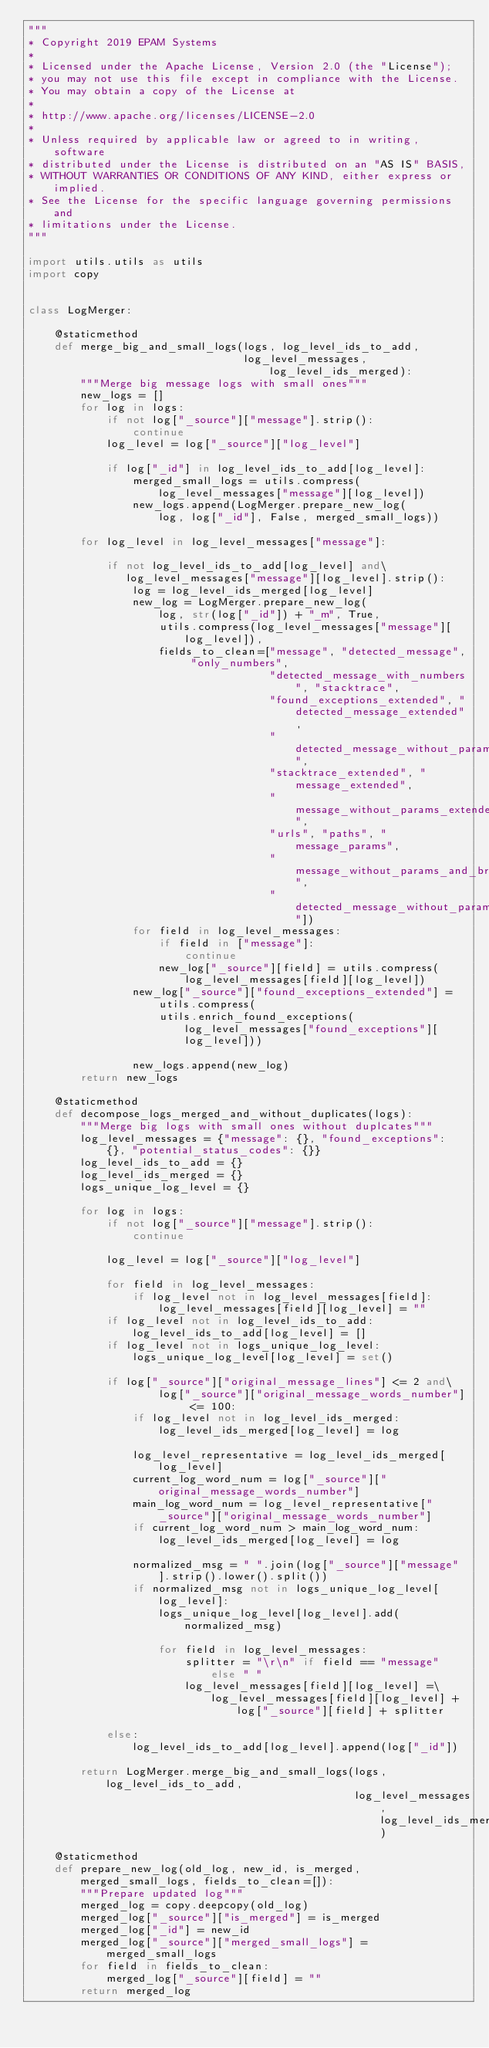<code> <loc_0><loc_0><loc_500><loc_500><_Python_>"""
* Copyright 2019 EPAM Systems
*
* Licensed under the Apache License, Version 2.0 (the "License");
* you may not use this file except in compliance with the License.
* You may obtain a copy of the License at
*
* http://www.apache.org/licenses/LICENSE-2.0
*
* Unless required by applicable law or agreed to in writing, software
* distributed under the License is distributed on an "AS IS" BASIS,
* WITHOUT WARRANTIES OR CONDITIONS OF ANY KIND, either express or implied.
* See the License for the specific language governing permissions and
* limitations under the License.
"""

import utils.utils as utils
import copy


class LogMerger:

    @staticmethod
    def merge_big_and_small_logs(logs, log_level_ids_to_add,
                                 log_level_messages, log_level_ids_merged):
        """Merge big message logs with small ones"""
        new_logs = []
        for log in logs:
            if not log["_source"]["message"].strip():
                continue
            log_level = log["_source"]["log_level"]

            if log["_id"] in log_level_ids_to_add[log_level]:
                merged_small_logs = utils.compress(log_level_messages["message"][log_level])
                new_logs.append(LogMerger.prepare_new_log(
                    log, log["_id"], False, merged_small_logs))

        for log_level in log_level_messages["message"]:

            if not log_level_ids_to_add[log_level] and\
               log_level_messages["message"][log_level].strip():
                log = log_level_ids_merged[log_level]
                new_log = LogMerger.prepare_new_log(
                    log, str(log["_id"]) + "_m", True,
                    utils.compress(log_level_messages["message"][log_level]),
                    fields_to_clean=["message", "detected_message", "only_numbers",
                                     "detected_message_with_numbers", "stacktrace",
                                     "found_exceptions_extended", "detected_message_extended",
                                     "detected_message_without_params_extended",
                                     "stacktrace_extended", "message_extended",
                                     "message_without_params_extended",
                                     "urls", "paths", "message_params",
                                     "message_without_params_and_brackets",
                                     "detected_message_without_params_and_brackets"])
                for field in log_level_messages:
                    if field in ["message"]:
                        continue
                    new_log["_source"][field] = utils.compress(
                        log_level_messages[field][log_level])
                new_log["_source"]["found_exceptions_extended"] = utils.compress(
                    utils.enrich_found_exceptions(log_level_messages["found_exceptions"][log_level]))

                new_logs.append(new_log)
        return new_logs

    @staticmethod
    def decompose_logs_merged_and_without_duplicates(logs):
        """Merge big logs with small ones without duplcates"""
        log_level_messages = {"message": {}, "found_exceptions": {}, "potential_status_codes": {}}
        log_level_ids_to_add = {}
        log_level_ids_merged = {}
        logs_unique_log_level = {}

        for log in logs:
            if not log["_source"]["message"].strip():
                continue

            log_level = log["_source"]["log_level"]

            for field in log_level_messages:
                if log_level not in log_level_messages[field]:
                    log_level_messages[field][log_level] = ""
            if log_level not in log_level_ids_to_add:
                log_level_ids_to_add[log_level] = []
            if log_level not in logs_unique_log_level:
                logs_unique_log_level[log_level] = set()

            if log["_source"]["original_message_lines"] <= 2 and\
                    log["_source"]["original_message_words_number"] <= 100:
                if log_level not in log_level_ids_merged:
                    log_level_ids_merged[log_level] = log

                log_level_representative = log_level_ids_merged[log_level]
                current_log_word_num = log["_source"]["original_message_words_number"]
                main_log_word_num = log_level_representative["_source"]["original_message_words_number"]
                if current_log_word_num > main_log_word_num:
                    log_level_ids_merged[log_level] = log

                normalized_msg = " ".join(log["_source"]["message"].strip().lower().split())
                if normalized_msg not in logs_unique_log_level[log_level]:
                    logs_unique_log_level[log_level].add(normalized_msg)

                    for field in log_level_messages:
                        splitter = "\r\n" if field == "message" else " "
                        log_level_messages[field][log_level] =\
                            log_level_messages[field][log_level] + log["_source"][field] + splitter

            else:
                log_level_ids_to_add[log_level].append(log["_id"])

        return LogMerger.merge_big_and_small_logs(logs, log_level_ids_to_add,
                                                  log_level_messages, log_level_ids_merged)

    @staticmethod
    def prepare_new_log(old_log, new_id, is_merged, merged_small_logs, fields_to_clean=[]):
        """Prepare updated log"""
        merged_log = copy.deepcopy(old_log)
        merged_log["_source"]["is_merged"] = is_merged
        merged_log["_id"] = new_id
        merged_log["_source"]["merged_small_logs"] = merged_small_logs
        for field in fields_to_clean:
            merged_log["_source"][field] = ""
        return merged_log
</code> 